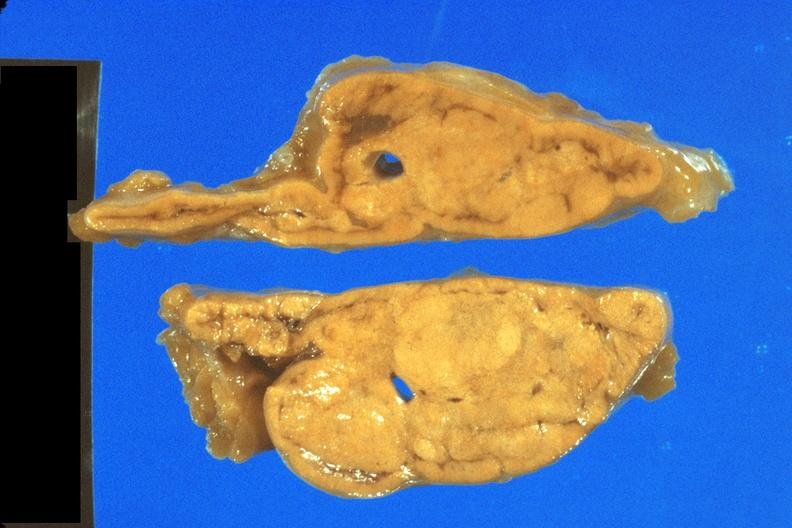s endocrine present?
Answer the question using a single word or phrase. Yes 